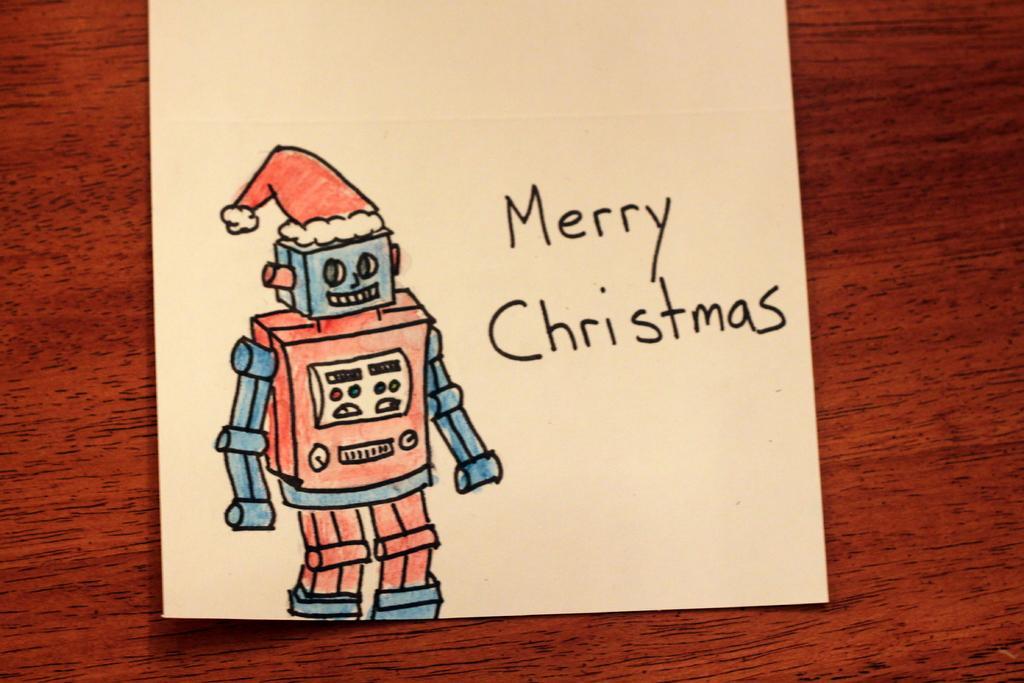How would you summarize this image in a sentence or two? In this image I can see sketch of robot and something written on the paper. This paper is on a wooden surface. 